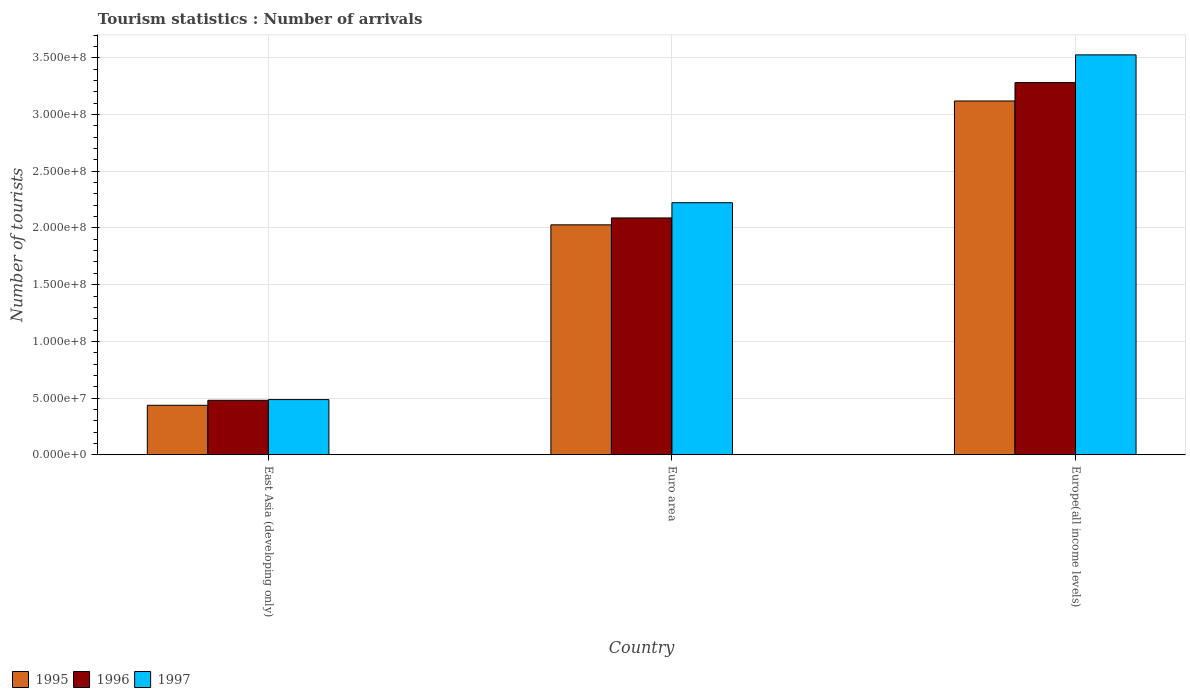Are the number of bars per tick equal to the number of legend labels?
Your answer should be very brief. Yes. Are the number of bars on each tick of the X-axis equal?
Make the answer very short. Yes. How many bars are there on the 2nd tick from the left?
Offer a very short reply. 3. What is the label of the 2nd group of bars from the left?
Keep it short and to the point. Euro area. What is the number of tourist arrivals in 1996 in East Asia (developing only)?
Your answer should be compact. 4.80e+07. Across all countries, what is the maximum number of tourist arrivals in 1995?
Provide a succinct answer. 3.12e+08. Across all countries, what is the minimum number of tourist arrivals in 1996?
Provide a succinct answer. 4.80e+07. In which country was the number of tourist arrivals in 1997 maximum?
Your response must be concise. Europe(all income levels). In which country was the number of tourist arrivals in 1997 minimum?
Keep it short and to the point. East Asia (developing only). What is the total number of tourist arrivals in 1997 in the graph?
Provide a succinct answer. 6.24e+08. What is the difference between the number of tourist arrivals in 1996 in East Asia (developing only) and that in Europe(all income levels)?
Offer a very short reply. -2.80e+08. What is the difference between the number of tourist arrivals in 1995 in Euro area and the number of tourist arrivals in 1996 in Europe(all income levels)?
Your answer should be very brief. -1.25e+08. What is the average number of tourist arrivals in 1996 per country?
Ensure brevity in your answer.  1.95e+08. What is the difference between the number of tourist arrivals of/in 1997 and number of tourist arrivals of/in 1995 in Europe(all income levels)?
Make the answer very short. 4.06e+07. In how many countries, is the number of tourist arrivals in 1996 greater than 230000000?
Ensure brevity in your answer.  1. What is the ratio of the number of tourist arrivals in 1997 in Euro area to that in Europe(all income levels)?
Give a very brief answer. 0.63. What is the difference between the highest and the second highest number of tourist arrivals in 1996?
Provide a short and direct response. -1.19e+08. What is the difference between the highest and the lowest number of tourist arrivals in 1995?
Provide a succinct answer. 2.68e+08. Is the sum of the number of tourist arrivals in 1995 in Euro area and Europe(all income levels) greater than the maximum number of tourist arrivals in 1997 across all countries?
Give a very brief answer. Yes. What does the 2nd bar from the right in Euro area represents?
Make the answer very short. 1996. How many bars are there?
Offer a very short reply. 9. Are all the bars in the graph horizontal?
Offer a terse response. No. How many countries are there in the graph?
Your answer should be very brief. 3. What is the difference between two consecutive major ticks on the Y-axis?
Provide a succinct answer. 5.00e+07. Does the graph contain grids?
Offer a terse response. Yes. How many legend labels are there?
Your answer should be compact. 3. What is the title of the graph?
Give a very brief answer. Tourism statistics : Number of arrivals. Does "2007" appear as one of the legend labels in the graph?
Ensure brevity in your answer.  No. What is the label or title of the X-axis?
Provide a succinct answer. Country. What is the label or title of the Y-axis?
Your response must be concise. Number of tourists. What is the Number of tourists of 1995 in East Asia (developing only)?
Offer a terse response. 4.36e+07. What is the Number of tourists of 1996 in East Asia (developing only)?
Keep it short and to the point. 4.80e+07. What is the Number of tourists of 1997 in East Asia (developing only)?
Provide a succinct answer. 4.87e+07. What is the Number of tourists in 1995 in Euro area?
Ensure brevity in your answer.  2.03e+08. What is the Number of tourists of 1996 in Euro area?
Offer a terse response. 2.09e+08. What is the Number of tourists of 1997 in Euro area?
Make the answer very short. 2.22e+08. What is the Number of tourists in 1995 in Europe(all income levels)?
Your response must be concise. 3.12e+08. What is the Number of tourists in 1996 in Europe(all income levels)?
Provide a succinct answer. 3.28e+08. What is the Number of tourists of 1997 in Europe(all income levels)?
Offer a very short reply. 3.53e+08. Across all countries, what is the maximum Number of tourists of 1995?
Provide a short and direct response. 3.12e+08. Across all countries, what is the maximum Number of tourists in 1996?
Offer a very short reply. 3.28e+08. Across all countries, what is the maximum Number of tourists in 1997?
Give a very brief answer. 3.53e+08. Across all countries, what is the minimum Number of tourists in 1995?
Provide a succinct answer. 4.36e+07. Across all countries, what is the minimum Number of tourists in 1996?
Your response must be concise. 4.80e+07. Across all countries, what is the minimum Number of tourists in 1997?
Provide a succinct answer. 4.87e+07. What is the total Number of tourists of 1995 in the graph?
Your answer should be compact. 5.58e+08. What is the total Number of tourists of 1996 in the graph?
Your response must be concise. 5.85e+08. What is the total Number of tourists of 1997 in the graph?
Keep it short and to the point. 6.24e+08. What is the difference between the Number of tourists in 1995 in East Asia (developing only) and that in Euro area?
Offer a terse response. -1.59e+08. What is the difference between the Number of tourists of 1996 in East Asia (developing only) and that in Euro area?
Offer a terse response. -1.61e+08. What is the difference between the Number of tourists of 1997 in East Asia (developing only) and that in Euro area?
Make the answer very short. -1.74e+08. What is the difference between the Number of tourists of 1995 in East Asia (developing only) and that in Europe(all income levels)?
Ensure brevity in your answer.  -2.68e+08. What is the difference between the Number of tourists of 1996 in East Asia (developing only) and that in Europe(all income levels)?
Give a very brief answer. -2.80e+08. What is the difference between the Number of tourists in 1997 in East Asia (developing only) and that in Europe(all income levels)?
Give a very brief answer. -3.04e+08. What is the difference between the Number of tourists of 1995 in Euro area and that in Europe(all income levels)?
Your response must be concise. -1.09e+08. What is the difference between the Number of tourists in 1996 in Euro area and that in Europe(all income levels)?
Provide a short and direct response. -1.19e+08. What is the difference between the Number of tourists of 1997 in Euro area and that in Europe(all income levels)?
Offer a terse response. -1.30e+08. What is the difference between the Number of tourists of 1995 in East Asia (developing only) and the Number of tourists of 1996 in Euro area?
Offer a very short reply. -1.65e+08. What is the difference between the Number of tourists of 1995 in East Asia (developing only) and the Number of tourists of 1997 in Euro area?
Provide a succinct answer. -1.79e+08. What is the difference between the Number of tourists in 1996 in East Asia (developing only) and the Number of tourists in 1997 in Euro area?
Your response must be concise. -1.74e+08. What is the difference between the Number of tourists in 1995 in East Asia (developing only) and the Number of tourists in 1996 in Europe(all income levels)?
Your response must be concise. -2.85e+08. What is the difference between the Number of tourists of 1995 in East Asia (developing only) and the Number of tourists of 1997 in Europe(all income levels)?
Offer a terse response. -3.09e+08. What is the difference between the Number of tourists of 1996 in East Asia (developing only) and the Number of tourists of 1997 in Europe(all income levels)?
Give a very brief answer. -3.05e+08. What is the difference between the Number of tourists in 1995 in Euro area and the Number of tourists in 1996 in Europe(all income levels)?
Ensure brevity in your answer.  -1.25e+08. What is the difference between the Number of tourists in 1995 in Euro area and the Number of tourists in 1997 in Europe(all income levels)?
Your response must be concise. -1.50e+08. What is the difference between the Number of tourists in 1996 in Euro area and the Number of tourists in 1997 in Europe(all income levels)?
Ensure brevity in your answer.  -1.44e+08. What is the average Number of tourists in 1995 per country?
Keep it short and to the point. 1.86e+08. What is the average Number of tourists of 1996 per country?
Offer a very short reply. 1.95e+08. What is the average Number of tourists of 1997 per country?
Provide a succinct answer. 2.08e+08. What is the difference between the Number of tourists of 1995 and Number of tourists of 1996 in East Asia (developing only)?
Provide a succinct answer. -4.40e+06. What is the difference between the Number of tourists in 1995 and Number of tourists in 1997 in East Asia (developing only)?
Give a very brief answer. -5.03e+06. What is the difference between the Number of tourists in 1996 and Number of tourists in 1997 in East Asia (developing only)?
Offer a very short reply. -6.36e+05. What is the difference between the Number of tourists of 1995 and Number of tourists of 1996 in Euro area?
Give a very brief answer. -6.07e+06. What is the difference between the Number of tourists in 1995 and Number of tourists in 1997 in Euro area?
Make the answer very short. -1.95e+07. What is the difference between the Number of tourists in 1996 and Number of tourists in 1997 in Euro area?
Ensure brevity in your answer.  -1.34e+07. What is the difference between the Number of tourists in 1995 and Number of tourists in 1996 in Europe(all income levels)?
Your answer should be very brief. -1.62e+07. What is the difference between the Number of tourists in 1995 and Number of tourists in 1997 in Europe(all income levels)?
Offer a very short reply. -4.06e+07. What is the difference between the Number of tourists of 1996 and Number of tourists of 1997 in Europe(all income levels)?
Provide a succinct answer. -2.44e+07. What is the ratio of the Number of tourists in 1995 in East Asia (developing only) to that in Euro area?
Your answer should be compact. 0.22. What is the ratio of the Number of tourists in 1996 in East Asia (developing only) to that in Euro area?
Your response must be concise. 0.23. What is the ratio of the Number of tourists of 1997 in East Asia (developing only) to that in Euro area?
Keep it short and to the point. 0.22. What is the ratio of the Number of tourists in 1995 in East Asia (developing only) to that in Europe(all income levels)?
Your answer should be very brief. 0.14. What is the ratio of the Number of tourists of 1996 in East Asia (developing only) to that in Europe(all income levels)?
Provide a succinct answer. 0.15. What is the ratio of the Number of tourists of 1997 in East Asia (developing only) to that in Europe(all income levels)?
Ensure brevity in your answer.  0.14. What is the ratio of the Number of tourists in 1995 in Euro area to that in Europe(all income levels)?
Make the answer very short. 0.65. What is the ratio of the Number of tourists of 1996 in Euro area to that in Europe(all income levels)?
Offer a terse response. 0.64. What is the ratio of the Number of tourists in 1997 in Euro area to that in Europe(all income levels)?
Provide a succinct answer. 0.63. What is the difference between the highest and the second highest Number of tourists in 1995?
Your response must be concise. 1.09e+08. What is the difference between the highest and the second highest Number of tourists of 1996?
Keep it short and to the point. 1.19e+08. What is the difference between the highest and the second highest Number of tourists of 1997?
Your answer should be compact. 1.30e+08. What is the difference between the highest and the lowest Number of tourists of 1995?
Ensure brevity in your answer.  2.68e+08. What is the difference between the highest and the lowest Number of tourists of 1996?
Your answer should be compact. 2.80e+08. What is the difference between the highest and the lowest Number of tourists of 1997?
Your answer should be compact. 3.04e+08. 